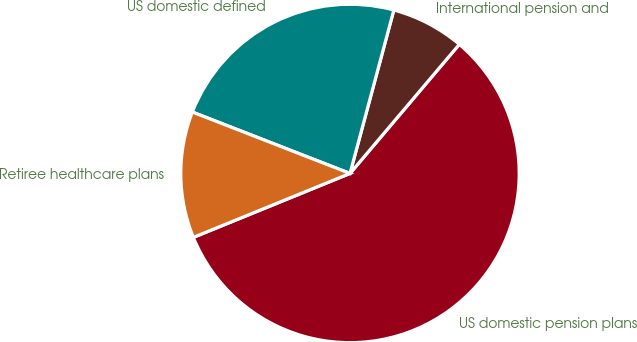<chart> <loc_0><loc_0><loc_500><loc_500><pie_chart><fcel>US domestic pension plans<fcel>International pension and<fcel>US domestic defined<fcel>Retiree healthcare plans<nl><fcel>57.65%<fcel>7.01%<fcel>23.26%<fcel>12.08%<nl></chart> 